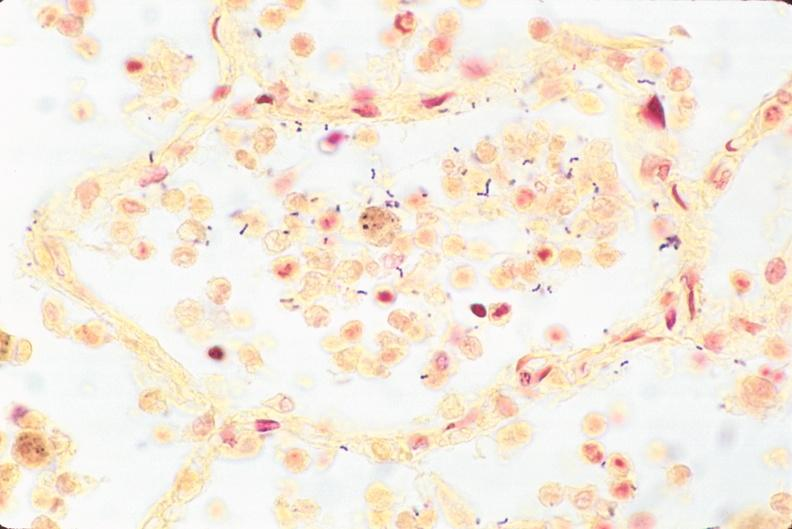what is present?
Answer the question using a single word or phrase. Respiratory 